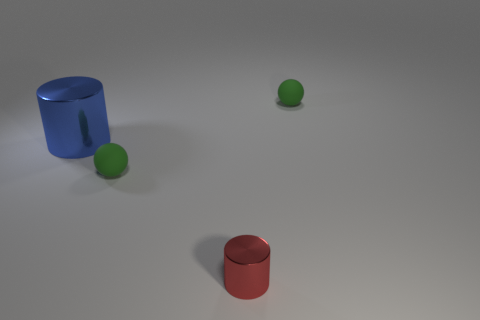There is a metallic cylinder behind the green matte thing in front of the rubber sphere right of the tiny red metal cylinder; what size is it?
Keep it short and to the point. Large. What color is the large metal object that is the same shape as the tiny red thing?
Your answer should be compact. Blue. Are there more big blue metallic cylinders on the left side of the small red thing than yellow objects?
Your answer should be very brief. Yes. Do the large object and the metal thing in front of the big blue shiny cylinder have the same shape?
Make the answer very short. Yes. Are there any other things that have the same size as the blue cylinder?
Provide a short and direct response. No. What size is the other blue object that is the same shape as the tiny metal thing?
Keep it short and to the point. Large. Is the number of blue things greater than the number of small yellow matte things?
Make the answer very short. Yes. Is the big thing the same shape as the tiny red metallic object?
Your response must be concise. Yes. What is the material of the tiny ball that is in front of the rubber ball behind the big shiny cylinder?
Provide a succinct answer. Rubber. Is the blue shiny cylinder the same size as the red object?
Keep it short and to the point. No. 